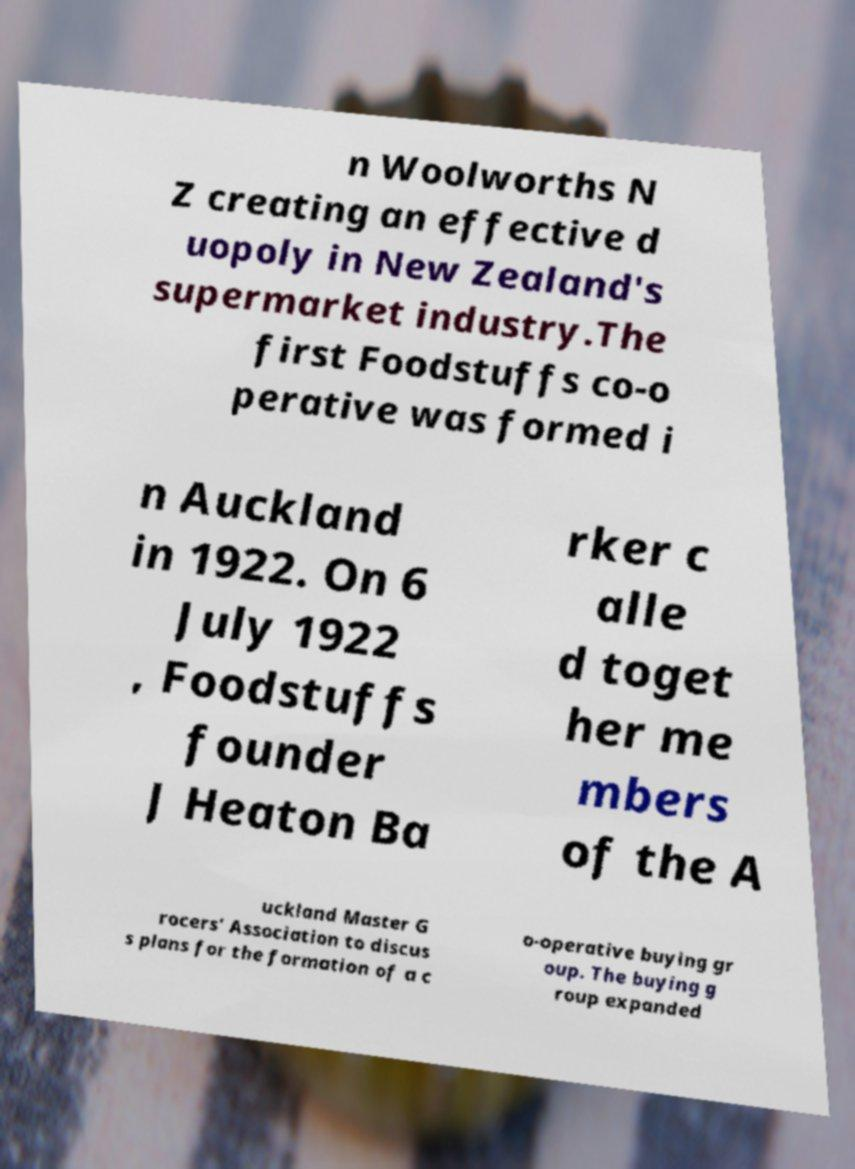Can you accurately transcribe the text from the provided image for me? n Woolworths N Z creating an effective d uopoly in New Zealand's supermarket industry.The first Foodstuffs co-o perative was formed i n Auckland in 1922. On 6 July 1922 , Foodstuffs founder J Heaton Ba rker c alle d toget her me mbers of the A uckland Master G rocers' Association to discus s plans for the formation of a c o-operative buying gr oup. The buying g roup expanded 